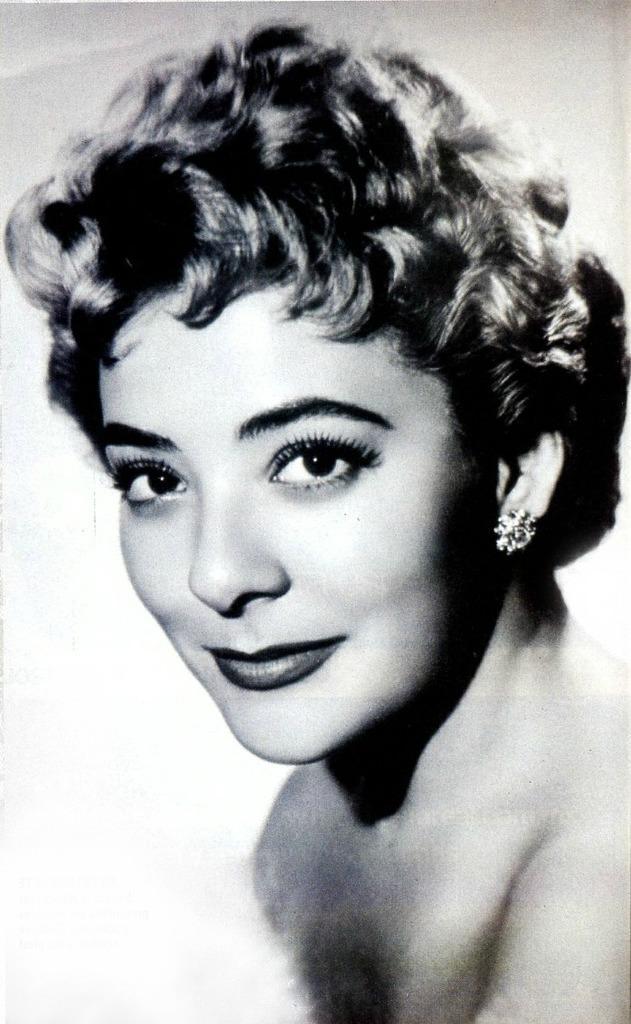How would you summarize this image in a sentence or two? In this picture we can see a woman, she is smiling, and it is a black and white photography. 